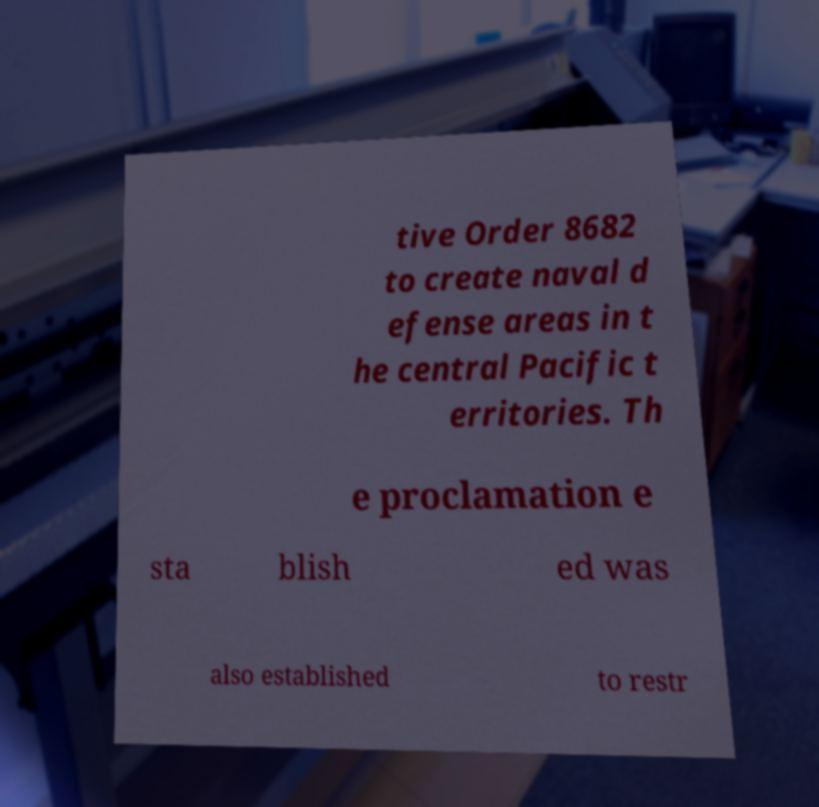Could you extract and type out the text from this image? tive Order 8682 to create naval d efense areas in t he central Pacific t erritories. Th e proclamation e sta blish ed was also established to restr 